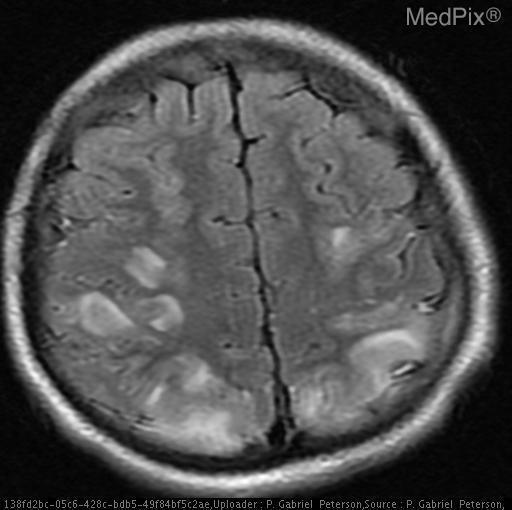Is there restricted diffusion?
Answer briefly. No. Is this a vascular lesion
Concise answer only. Yes. Does this lesion involve the vascular system?
Keep it brief. Yes. What is the most likely etiology
Write a very short answer. Viral/inflammatory. What is most likely causing these lesions?
Quick response, please. Cva. The pathology is located in which lobes of the brain?
Write a very short answer. Parietal and occipital lobes. Which lobes demonstrate pathology
Write a very short answer. Parietal and occipital lobes. 